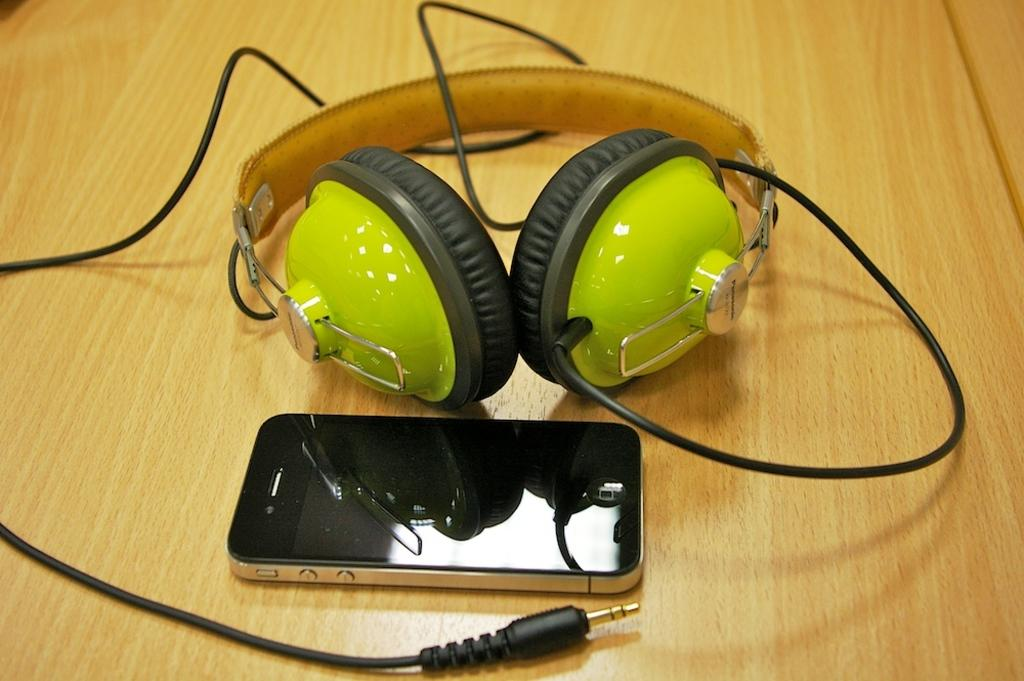What type of audio device is present in the image? There are headphones with a cable in the image. What electronic device is also visible in the image? There is a mobile phone in the image. On what surface are the headphones and mobile phone placed? The headphones and mobile phone are placed on a wooden surface. What is the weight of the screw that is holding the headphones in place? There is no screw visible in the image, and therefore no such weight can be determined. How many bikes are parked next to the wooden surface in the image? There are no bikes present in the image. 